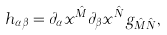<formula> <loc_0><loc_0><loc_500><loc_500>h _ { \alpha \beta } = \partial _ { \alpha } x ^ { \hat { M } } \partial _ { \beta } x ^ { \hat { N } } g _ { { \hat { M } } { \hat { N } } } ,</formula> 